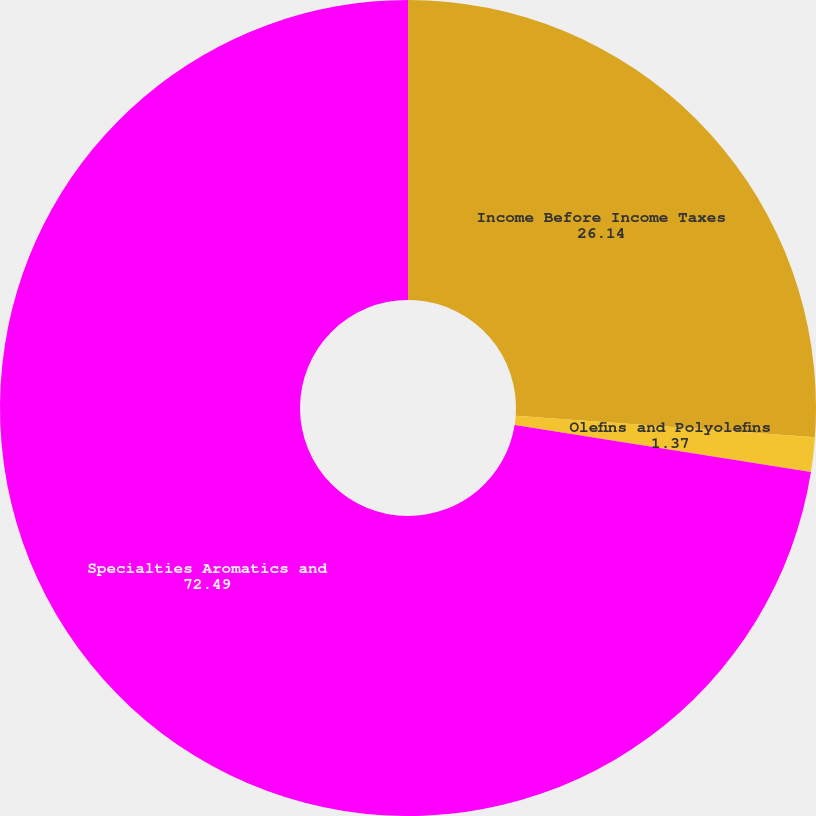Convert chart to OTSL. <chart><loc_0><loc_0><loc_500><loc_500><pie_chart><fcel>Income Before Income Taxes<fcel>Olefins and Polyolefins<fcel>Specialties Aromatics and<nl><fcel>26.14%<fcel>1.37%<fcel>72.49%<nl></chart> 